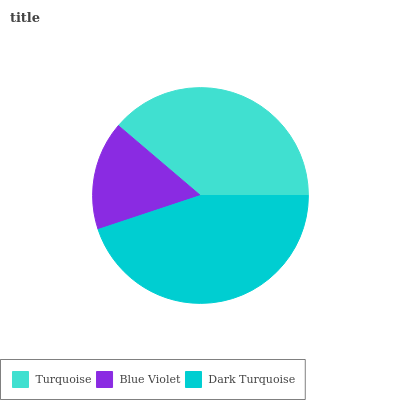Is Blue Violet the minimum?
Answer yes or no. Yes. Is Dark Turquoise the maximum?
Answer yes or no. Yes. Is Dark Turquoise the minimum?
Answer yes or no. No. Is Blue Violet the maximum?
Answer yes or no. No. Is Dark Turquoise greater than Blue Violet?
Answer yes or no. Yes. Is Blue Violet less than Dark Turquoise?
Answer yes or no. Yes. Is Blue Violet greater than Dark Turquoise?
Answer yes or no. No. Is Dark Turquoise less than Blue Violet?
Answer yes or no. No. Is Turquoise the high median?
Answer yes or no. Yes. Is Turquoise the low median?
Answer yes or no. Yes. Is Blue Violet the high median?
Answer yes or no. No. Is Dark Turquoise the low median?
Answer yes or no. No. 